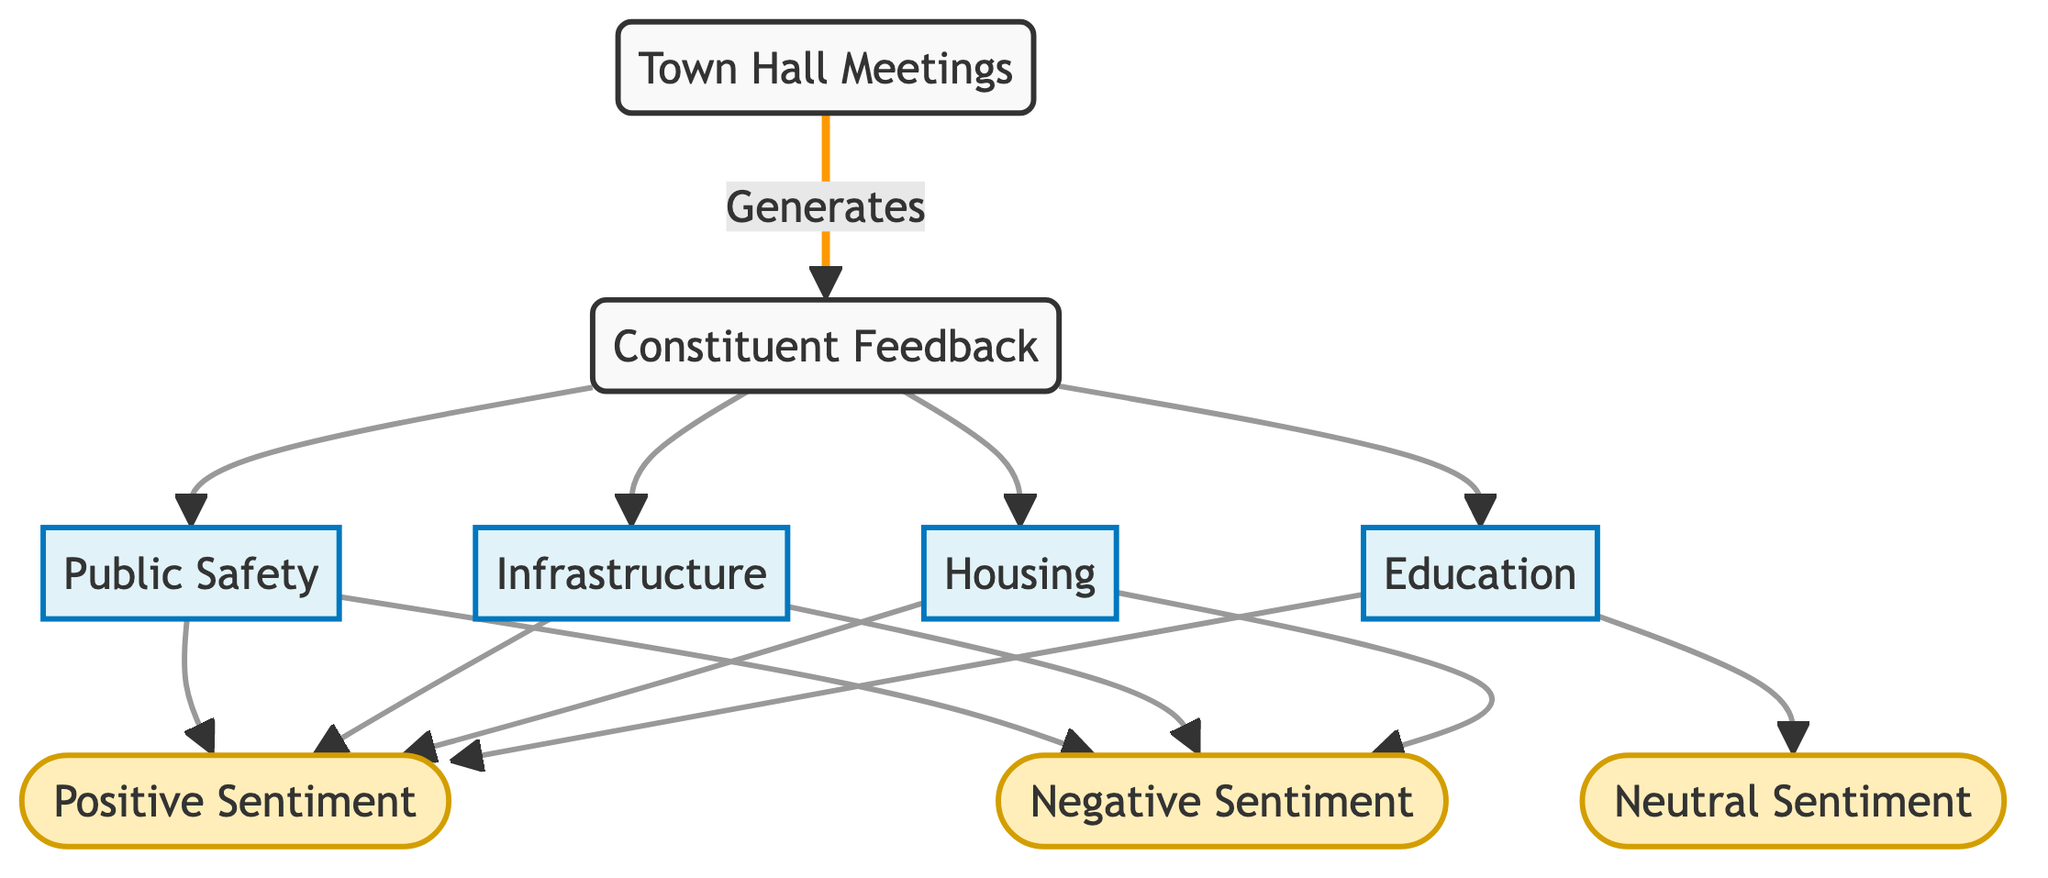What is the total number of nodes in the diagram? The diagram lists different constituents such as 'Constituent Feedback', 'Town Hall Meetings', 'Public Safety', 'Infrastructure', 'Housing', 'Education', 'Positive Sentiment', 'Negative Sentiment', and 'Neutral Sentiment'. Adding these up, there are 8 nodes.
Answer: 8 Which sentiment is associated with Public Safety? In the diagram, 'Public Safety' has directed edges leading to 'Positive Sentiment' and 'Negative Sentiment', indicating both sentiments are connected to it.
Answer: Positive Sentiment, Negative Sentiment How many topics are directly linked to Constituent Feedback? 'Constituent Feedback' has directed edges going to four topics: 'Public Safety', 'Infrastructure', 'Housing', and 'Education'. Counting these gives a total of 4.
Answer: 4 Which sentiment does Education point to? The node 'Education' has directed edges leading to 'Positive Sentiment' and 'Neutral Sentiment'. Therefore, the sentiments associated with 'Education' are both of these.
Answer: Positive Sentiment, Neutral Sentiment What is the relationship between Town Hall Meetings and Constituent Feedback? The diagram illustrates that 'Town Hall Meetings' generates 'Constituent Feedback', indicating a direct causal relationship from the town hall meetings to the feedback received.
Answer: Generates How many sentiments are linked to Infrastructure? 'Infrastructure' has directed edges connecting to 'Positive Sentiment' and 'Negative Sentiment', which totals 2 sentimental connections.
Answer: 2 Is there any neutral sentiment connected to Public Safety? Analyzing the diagram shows that 'Public Safety' is only connected to 'Positive Sentiment' and 'Negative Sentiment', with no edge leading to 'Neutral Sentiment'.
Answer: No Which category does Housing fall under? The node 'Housing' is categorized as a topic based on its connection to 'Constituent Feedback', aligning it with the other topics present in the diagram.
Answer: Topic What type of feedback does Constituent Feedback deliver? The 'Constituent Feedback' node connects to 'Public Safety', 'Infrastructure', 'Housing', and 'Education', which all represent specific areas of feedback provided by constituents during meetings.
Answer: Feedback by Topic 